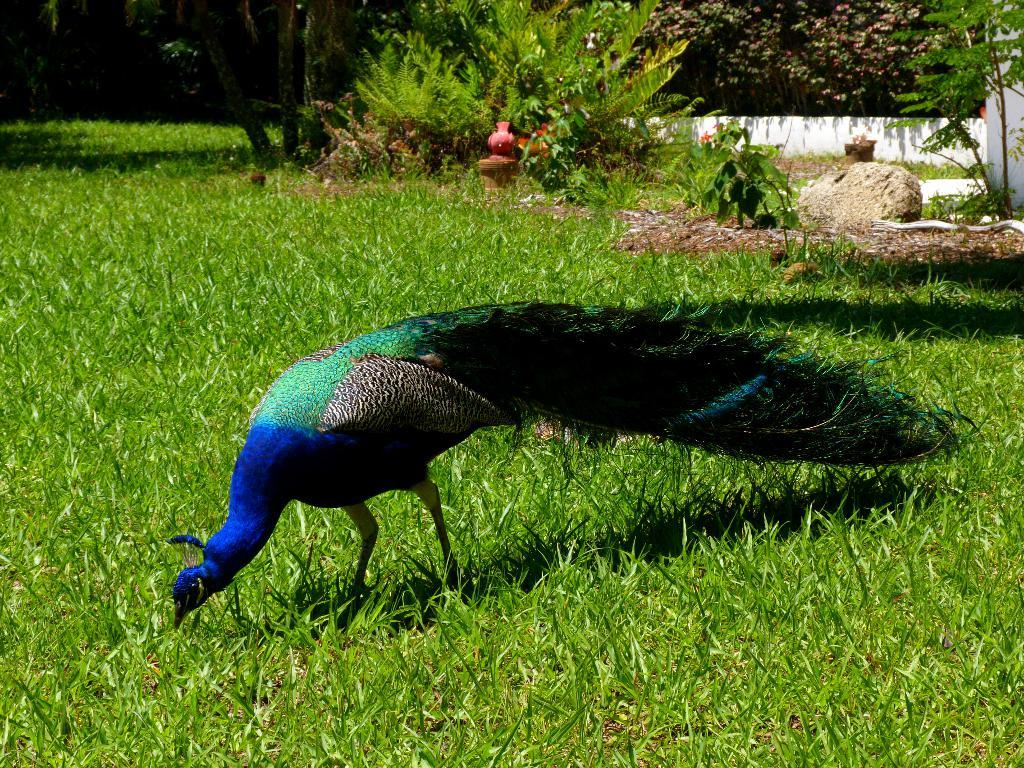What type of animal is in the image? There is a peacock in the image. What type of vegetation is present in the image? There is grass, a plant, and trees in the image. What other objects can be seen in the image? There is a stone and a small wall in the image. Can you see the cow stretching its finger in the image? There is no cow or stretching finger present in the image. 